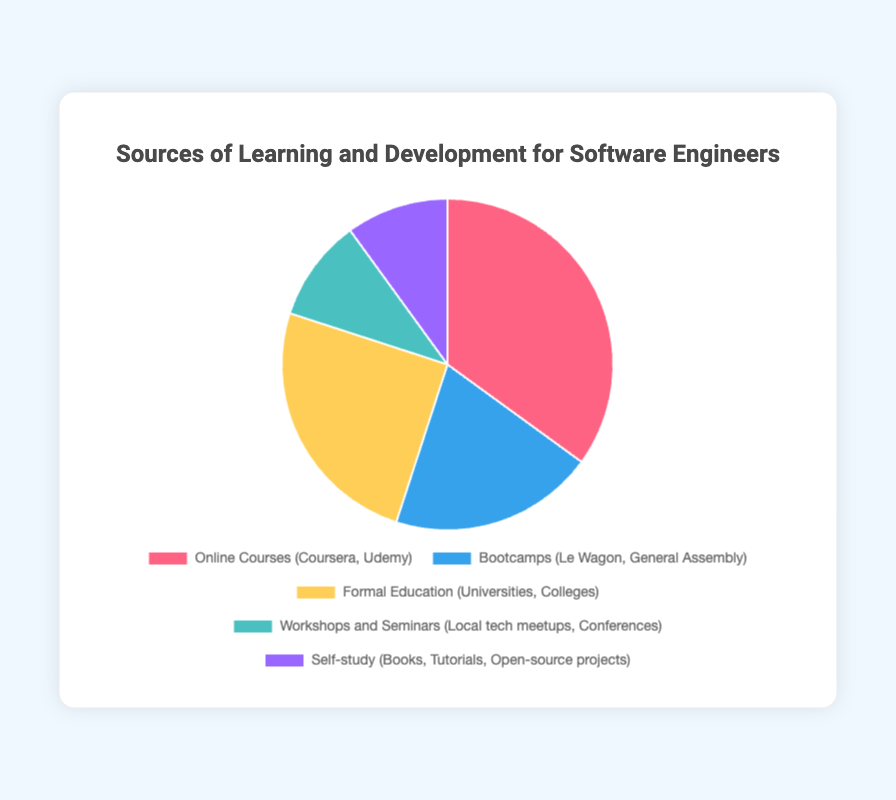Which source of learning and development has the highest percentage? The source of learning and development with the highest percentage is represented by the data point with the largest pie segment. In the figure, this is "Online Courses (Coursera, Udemy)" with 35%.
Answer: Online Courses (Coursera, Udemy) Which two sources of learning and development have the same percentage? By examining the pie chart, we can see that the segments for Workshops and Seminars (Local tech meetups, Conferences) and Self-study (Books, Tutorials, Open-source projects) are the same size, each representing 10%.
Answer: Workshops and Seminars, Self-study Which is greater, the percentage of Bootcamps or Formal Education, and by how much? Compare the segments for Bootcamps and Formal Education. Bootcamps account for 20%, whereas Formal Education accounts for 25%. The difference is 25% - 20% = 5%.
Answer: Formal Education, 5% What is the total percentage of sources that contribute less than 15% each? Identify segments with less than 15% each: Workshops and Seminars (10%) and Self-study (10%). Sum these percentages: 10% + 10% = 20%.
Answer: 20% What's the difference between the highest and lowest percentages among the sources? The highest percentage is for Online Courses (35%) and the lowest is for both Workshops and Seminars and Self-study (10%). The difference is 35% - 10% = 25%.
Answer: 25% What is the average percentage of the five sources of learning and development? To find the average, sum all percentages and divide by the number of sources. The sum is 35% + 20% + 25% + 10% + 10% = 100%. The average is 100% / 5 = 20%.
Answer: 20% How much more popular are Online Courses compared to Bootcamps? Online Courses account for 35%, and Bootcamps account for 20%. The difference in popularity is 35% - 20% = 15%.
Answer: 15% If you combine the percentages for Formal Education and Bootcamps, what is the resulting percentage? Sum the percentages for Formal Education (25%) and Bootcamps (20%). The resulting percentage is 25% + 20% = 45%.
Answer: 45% Which color represents the source with the smallest percentage, and what is the source? Identify the color for the smallest segments (10%), which are Workshops and Seminars, and Self-study. The colors are light green and light purple respectively.
Answer: Light green, Light purple; Workshops and Seminars, Self-study What is the percentage difference between the most popular and second most popular sources of learning? The most popular source is Online Courses (35%), and the second most popular is Formal Education (25%). The difference is 35% - 25% = 10%.
Answer: 10% 